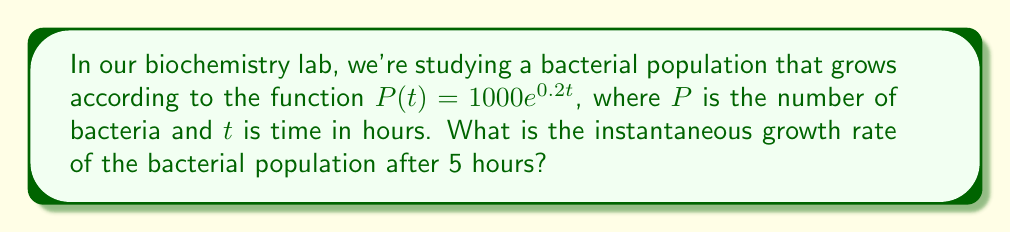Solve this math problem. To find the instantaneous growth rate, we need to calculate the derivative of the population function at t = 5 hours. Let's approach this step-by-step:

1) The given function is $P(t) = 1000e^{0.2t}$

2) To find the derivative, we use the chain rule:
   $$\frac{d}{dt}[P(t)] = 1000 \cdot \frac{d}{dt}[e^{0.2t}]$$

3) The derivative of $e^x$ is $e^x$, so:
   $$\frac{d}{dt}[P(t)] = 1000 \cdot 0.2e^{0.2t}$$

4) Simplify:
   $$\frac{d}{dt}[P(t)] = 200e^{0.2t}$$

5) This derivative represents the instantaneous growth rate at any time t.

6) To find the growth rate at t = 5 hours, we substitute t = 5 into our derivative:
   $$\frac{d}{dt}[P(5)] = 200e^{0.2(5)} = 200e^1$$

7) Calculate:
   $$200e^1 \approx 200 \cdot 2.71828 \approx 543.656$$

Therefore, the instantaneous growth rate after 5 hours is approximately 543.656 bacteria per hour.
Answer: 543.656 bacteria/hour 